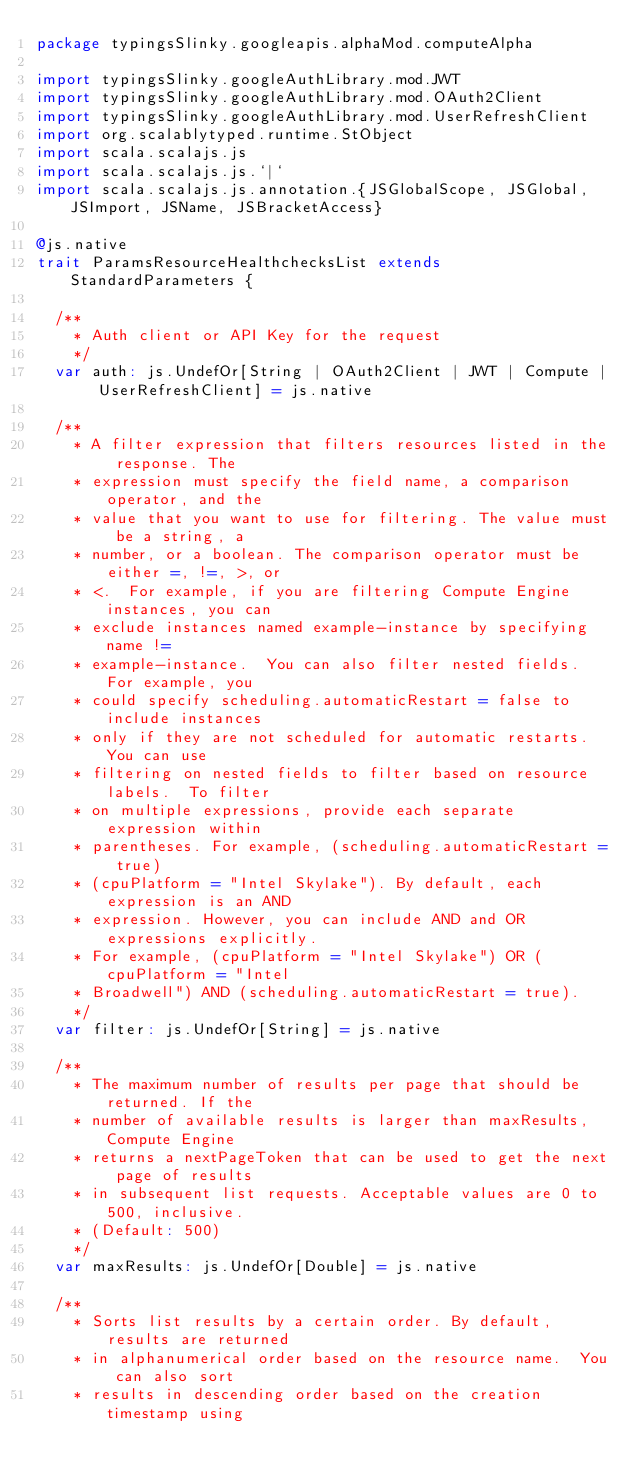<code> <loc_0><loc_0><loc_500><loc_500><_Scala_>package typingsSlinky.googleapis.alphaMod.computeAlpha

import typingsSlinky.googleAuthLibrary.mod.JWT
import typingsSlinky.googleAuthLibrary.mod.OAuth2Client
import typingsSlinky.googleAuthLibrary.mod.UserRefreshClient
import org.scalablytyped.runtime.StObject
import scala.scalajs.js
import scala.scalajs.js.`|`
import scala.scalajs.js.annotation.{JSGlobalScope, JSGlobal, JSImport, JSName, JSBracketAccess}

@js.native
trait ParamsResourceHealthchecksList extends StandardParameters {
  
  /**
    * Auth client or API Key for the request
    */
  var auth: js.UndefOr[String | OAuth2Client | JWT | Compute | UserRefreshClient] = js.native
  
  /**
    * A filter expression that filters resources listed in the response. The
    * expression must specify the field name, a comparison operator, and the
    * value that you want to use for filtering. The value must be a string, a
    * number, or a boolean. The comparison operator must be either =, !=, >, or
    * <.  For example, if you are filtering Compute Engine instances, you can
    * exclude instances named example-instance by specifying name !=
    * example-instance.  You can also filter nested fields. For example, you
    * could specify scheduling.automaticRestart = false to include instances
    * only if they are not scheduled for automatic restarts. You can use
    * filtering on nested fields to filter based on resource labels.  To filter
    * on multiple expressions, provide each separate expression within
    * parentheses. For example, (scheduling.automaticRestart = true)
    * (cpuPlatform = "Intel Skylake"). By default, each expression is an AND
    * expression. However, you can include AND and OR expressions explicitly.
    * For example, (cpuPlatform = "Intel Skylake") OR (cpuPlatform = "Intel
    * Broadwell") AND (scheduling.automaticRestart = true).
    */
  var filter: js.UndefOr[String] = js.native
  
  /**
    * The maximum number of results per page that should be returned. If the
    * number of available results is larger than maxResults, Compute Engine
    * returns a nextPageToken that can be used to get the next page of results
    * in subsequent list requests. Acceptable values are 0 to 500, inclusive.
    * (Default: 500)
    */
  var maxResults: js.UndefOr[Double] = js.native
  
  /**
    * Sorts list results by a certain order. By default, results are returned
    * in alphanumerical order based on the resource name.  You can also sort
    * results in descending order based on the creation timestamp using</code> 